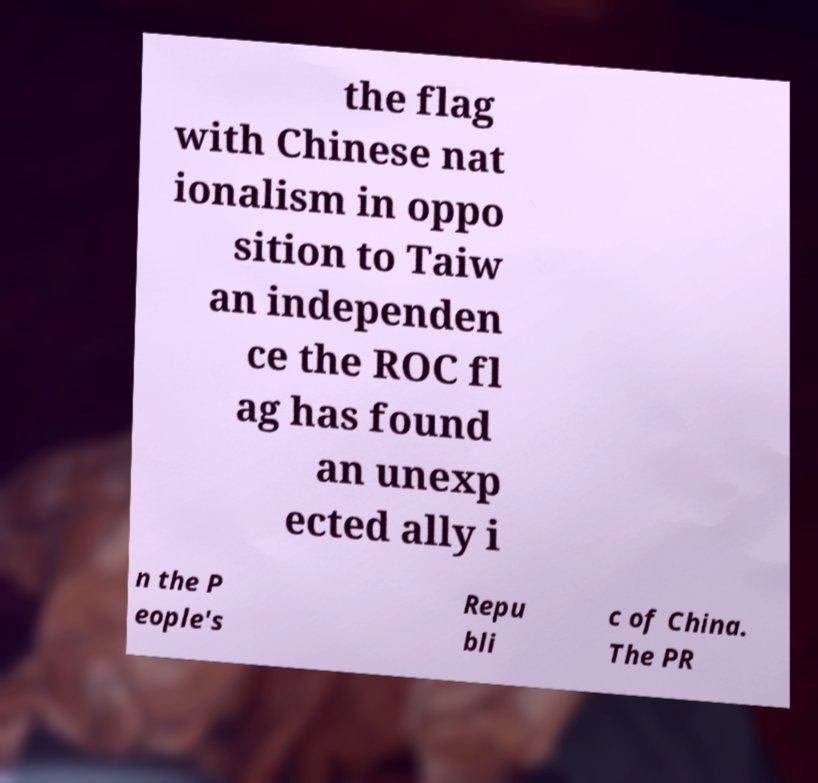I need the written content from this picture converted into text. Can you do that? the flag with Chinese nat ionalism in oppo sition to Taiw an independen ce the ROC fl ag has found an unexp ected ally i n the P eople's Repu bli c of China. The PR 